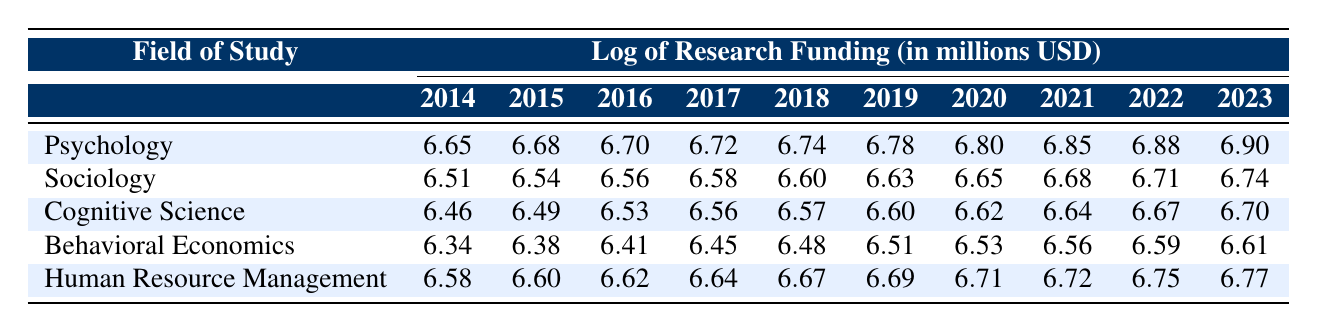What was the research funding amount for Psychology in 2023? The table shows the log of research funding in millions for each field of study across the years. To find the value for Psychology in 2023, we can look at the last column corresponding to 2023. The value is 6.90.
Answer: 6.90 Which field of study received the highest funding in 2020? By comparing the values for each field in the 2020 column, we can see that Psychology has the highest value at 6.80 compared to the other fields.
Answer: Psychology What is the difference in funding for Sociology between 2014 and 2023? The funding for Sociology in 2014 is shown as 6.51 and in 2023 as 6.74. To find the difference, we subtract 6.51 from 6.74, which gives us 0.23.
Answer: 0.23 Did Cognitive Science have more funding in 2021 than Behavioral Economics in 2020? In the table, the funding for Cognitive Science in 2021 is 6.64 and for Behavioral Economics in 2020 is 6.53. Since 6.64 is greater than 6.53, the statement is true.
Answer: Yes What is the average funding amount for Human Resource Management over the last decade? To find the average, we first need to add the values for Human Resource Management from 2014 to 2023: 6.58 + 6.60 + 6.62 + 6.64 + 6.67 + 6.69 + 6.71 + 6.72 + 6.75 + 6.77 = 66.52. There are 10 data points, so we divide 66.52 by 10, which equals 6.652.
Answer: 6.652 Which field of study shows the highest overall increase in funding from 2014 to 2023? To determine this, we look at the funding values for each field in 2014 and 2023: Psychology (6.65 to 6.90 = +0.25), Sociology (6.51 to 6.74 = +0.23), Cognitive Science (6.46 to 6.70 = +0.24), Behavioral Economics (6.34 to 6.61 = +0.27), and Human Resource Management (6.58 to 6.77 = +0.19). The highest increase is observed in Behavioral Economics, with an increase of 0.27.
Answer: Behavioral Economics Was the funding for Sociology in 2021 greater than that for Human Resource Management in 2016? The funding for Sociology in 2021 is 6.68, and for Human Resource Management in 2016, it is 6.62. Since 6.68 is greater than 6.62, the answer is true.
Answer: Yes What is the total funding for Cognitive Science from 2019 to 2023? To find the total, we sum the values for Cognitive Science from the years 2019 to 2023: 6.60 + 6.62 + 6.67 + 6.70 = 26.59.
Answer: 26.59 